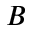Convert formula to latex. <formula><loc_0><loc_0><loc_500><loc_500>B</formula> 